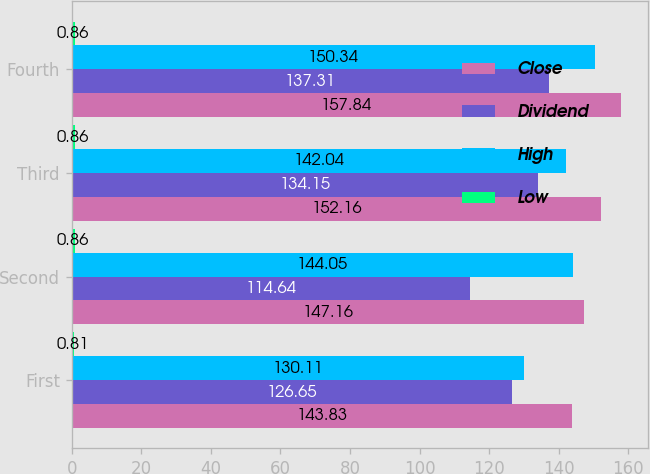Convert chart. <chart><loc_0><loc_0><loc_500><loc_500><stacked_bar_chart><ecel><fcel>First<fcel>Second<fcel>Third<fcel>Fourth<nl><fcel>Close<fcel>143.83<fcel>147.16<fcel>152.16<fcel>157.84<nl><fcel>Dividend<fcel>126.65<fcel>114.64<fcel>134.15<fcel>137.31<nl><fcel>High<fcel>130.11<fcel>144.05<fcel>142.04<fcel>150.34<nl><fcel>Low<fcel>0.81<fcel>0.86<fcel>0.86<fcel>0.86<nl></chart> 